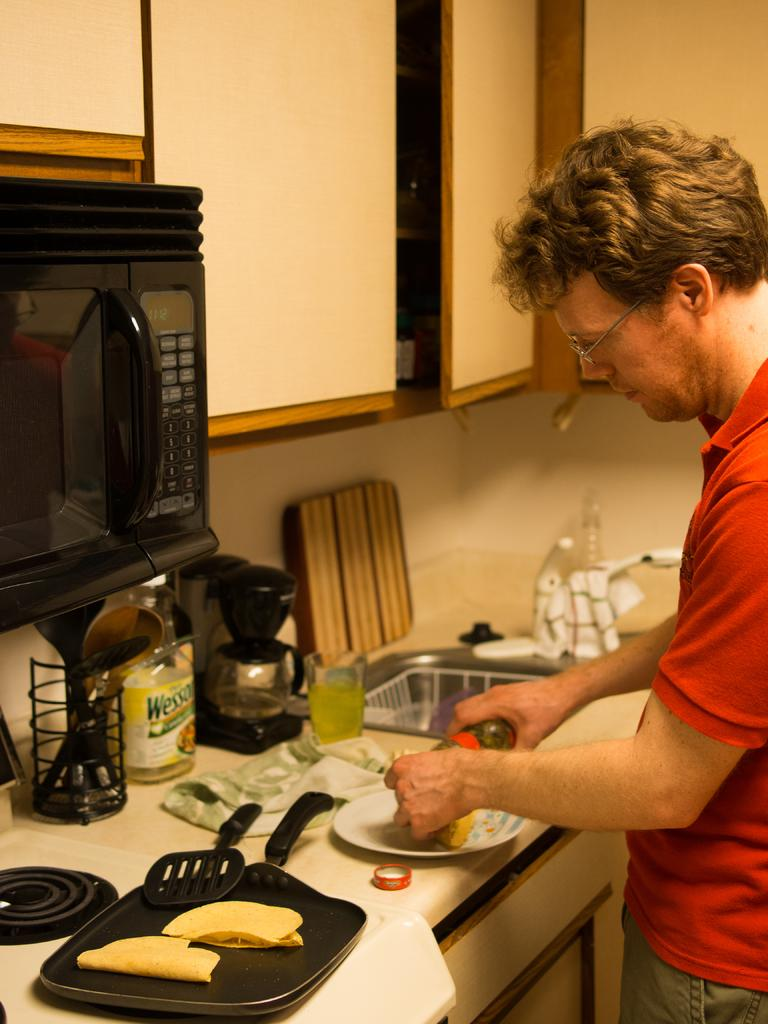<image>
Write a terse but informative summary of the picture. A man is cooking at the kitchen counter that holds a Wesson Oil bottle along with a coffee maker and other things. 